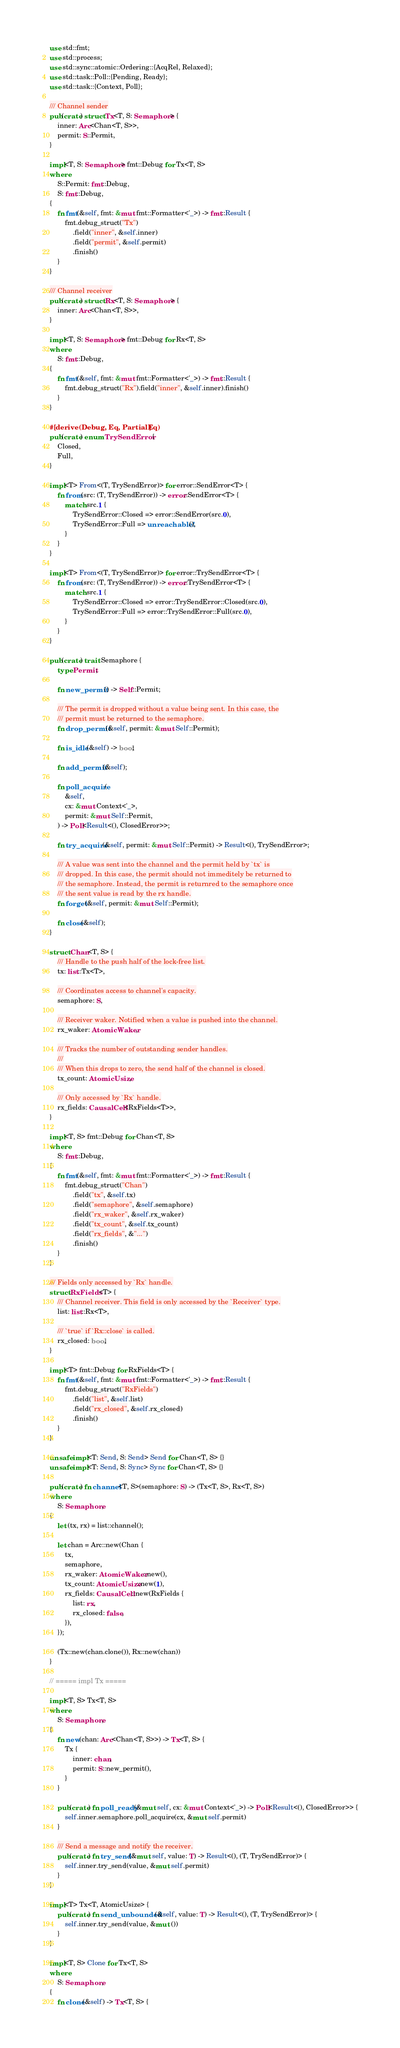Convert code to text. <code><loc_0><loc_0><loc_500><loc_500><_Rust_>
use std::fmt;
use std::process;
use std::sync::atomic::Ordering::{AcqRel, Relaxed};
use std::task::Poll::{Pending, Ready};
use std::task::{Context, Poll};

/// Channel sender
pub(crate) struct Tx<T, S: Semaphore> {
    inner: Arc<Chan<T, S>>,
    permit: S::Permit,
}

impl<T, S: Semaphore> fmt::Debug for Tx<T, S>
where
    S::Permit: fmt::Debug,
    S: fmt::Debug,
{
    fn fmt(&self, fmt: &mut fmt::Formatter<'_>) -> fmt::Result {
        fmt.debug_struct("Tx")
            .field("inner", &self.inner)
            .field("permit", &self.permit)
            .finish()
    }
}

/// Channel receiver
pub(crate) struct Rx<T, S: Semaphore> {
    inner: Arc<Chan<T, S>>,
}

impl<T, S: Semaphore> fmt::Debug for Rx<T, S>
where
    S: fmt::Debug,
{
    fn fmt(&self, fmt: &mut fmt::Formatter<'_>) -> fmt::Result {
        fmt.debug_struct("Rx").field("inner", &self.inner).finish()
    }
}

#[derive(Debug, Eq, PartialEq)]
pub(crate) enum TrySendError {
    Closed,
    Full,
}

impl<T> From<(T, TrySendError)> for error::SendError<T> {
    fn from(src: (T, TrySendError)) -> error::SendError<T> {
        match src.1 {
            TrySendError::Closed => error::SendError(src.0),
            TrySendError::Full => unreachable!(),
        }
    }
}

impl<T> From<(T, TrySendError)> for error::TrySendError<T> {
    fn from(src: (T, TrySendError)) -> error::TrySendError<T> {
        match src.1 {
            TrySendError::Closed => error::TrySendError::Closed(src.0),
            TrySendError::Full => error::TrySendError::Full(src.0),
        }
    }
}

pub(crate) trait Semaphore {
    type Permit;

    fn new_permit() -> Self::Permit;

    /// The permit is dropped without a value being sent. In this case, the
    /// permit must be returned to the semaphore.
    fn drop_permit(&self, permit: &mut Self::Permit);

    fn is_idle(&self) -> bool;

    fn add_permit(&self);

    fn poll_acquire(
        &self,
        cx: &mut Context<'_>,
        permit: &mut Self::Permit,
    ) -> Poll<Result<(), ClosedError>>;

    fn try_acquire(&self, permit: &mut Self::Permit) -> Result<(), TrySendError>;

    /// A value was sent into the channel and the permit held by `tx` is
    /// dropped. In this case, the permit should not immeditely be returned to
    /// the semaphore. Instead, the permit is returnred to the semaphore once
    /// the sent value is read by the rx handle.
    fn forget(&self, permit: &mut Self::Permit);

    fn close(&self);
}

struct Chan<T, S> {
    /// Handle to the push half of the lock-free list.
    tx: list::Tx<T>,

    /// Coordinates access to channel's capacity.
    semaphore: S,

    /// Receiver waker. Notified when a value is pushed into the channel.
    rx_waker: AtomicWaker,

    /// Tracks the number of outstanding sender handles.
    ///
    /// When this drops to zero, the send half of the channel is closed.
    tx_count: AtomicUsize,

    /// Only accessed by `Rx` handle.
    rx_fields: CausalCell<RxFields<T>>,
}

impl<T, S> fmt::Debug for Chan<T, S>
where
    S: fmt::Debug,
{
    fn fmt(&self, fmt: &mut fmt::Formatter<'_>) -> fmt::Result {
        fmt.debug_struct("Chan")
            .field("tx", &self.tx)
            .field("semaphore", &self.semaphore)
            .field("rx_waker", &self.rx_waker)
            .field("tx_count", &self.tx_count)
            .field("rx_fields", &"...")
            .finish()
    }
}

/// Fields only accessed by `Rx` handle.
struct RxFields<T> {
    /// Channel receiver. This field is only accessed by the `Receiver` type.
    list: list::Rx<T>,

    /// `true` if `Rx::close` is called.
    rx_closed: bool,
}

impl<T> fmt::Debug for RxFields<T> {
    fn fmt(&self, fmt: &mut fmt::Formatter<'_>) -> fmt::Result {
        fmt.debug_struct("RxFields")
            .field("list", &self.list)
            .field("rx_closed", &self.rx_closed)
            .finish()
    }
}

unsafe impl<T: Send, S: Send> Send for Chan<T, S> {}
unsafe impl<T: Send, S: Sync> Sync for Chan<T, S> {}

pub(crate) fn channel<T, S>(semaphore: S) -> (Tx<T, S>, Rx<T, S>)
where
    S: Semaphore,
{
    let (tx, rx) = list::channel();

    let chan = Arc::new(Chan {
        tx,
        semaphore,
        rx_waker: AtomicWaker::new(),
        tx_count: AtomicUsize::new(1),
        rx_fields: CausalCell::new(RxFields {
            list: rx,
            rx_closed: false,
        }),
    });

    (Tx::new(chan.clone()), Rx::new(chan))
}

// ===== impl Tx =====

impl<T, S> Tx<T, S>
where
    S: Semaphore,
{
    fn new(chan: Arc<Chan<T, S>>) -> Tx<T, S> {
        Tx {
            inner: chan,
            permit: S::new_permit(),
        }
    }

    pub(crate) fn poll_ready(&mut self, cx: &mut Context<'_>) -> Poll<Result<(), ClosedError>> {
        self.inner.semaphore.poll_acquire(cx, &mut self.permit)
    }

    /// Send a message and notify the receiver.
    pub(crate) fn try_send(&mut self, value: T) -> Result<(), (T, TrySendError)> {
        self.inner.try_send(value, &mut self.permit)
    }
}

impl<T> Tx<T, AtomicUsize> {
    pub(crate) fn send_unbounded(&self, value: T) -> Result<(), (T, TrySendError)> {
        self.inner.try_send(value, &mut ())
    }
}

impl<T, S> Clone for Tx<T, S>
where
    S: Semaphore,
{
    fn clone(&self) -> Tx<T, S> {</code> 